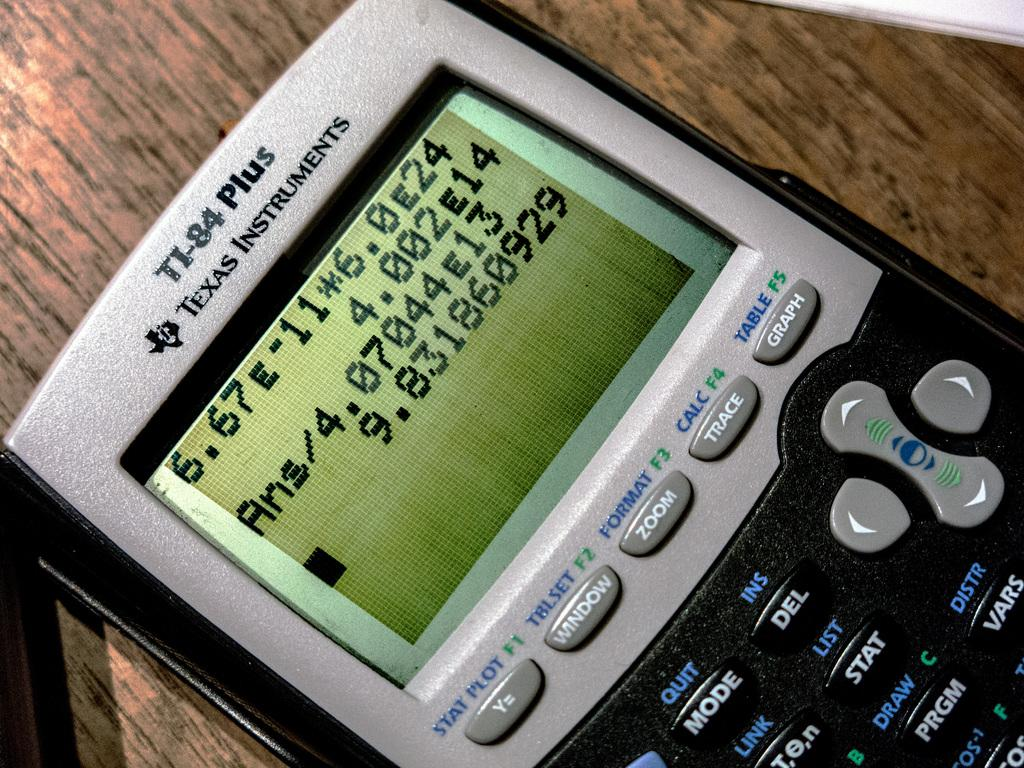<image>
Give a short and clear explanation of the subsequent image. A TI-84 Plus Texas Instruments electronic device lying on a table. 